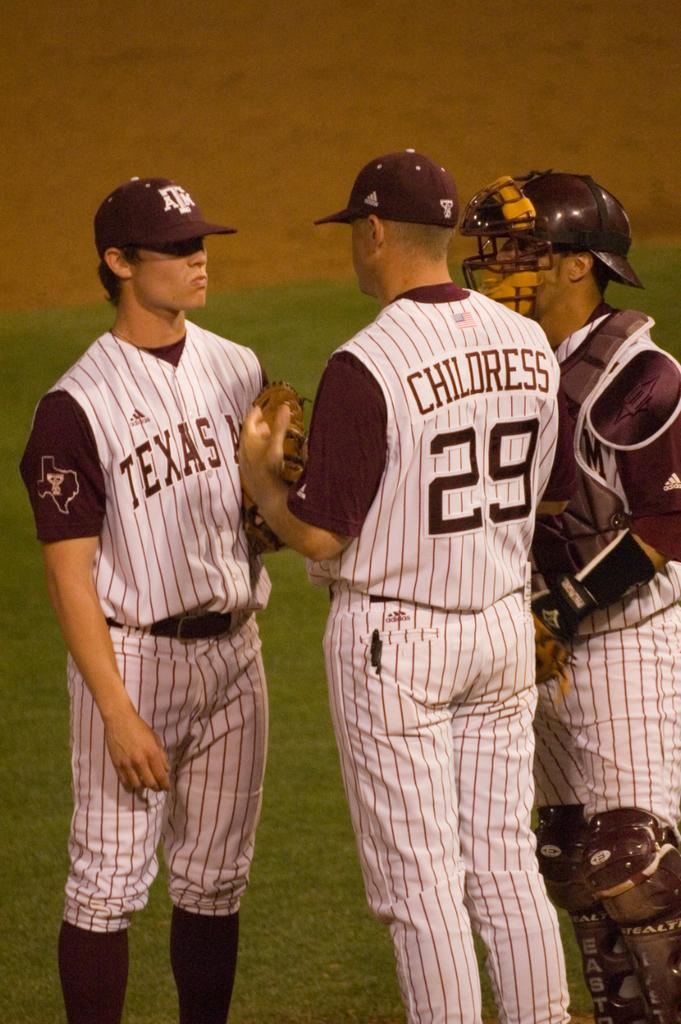What state is on the shirt of the men?
Provide a short and direct response. Texas. What number is childress?
Your answer should be very brief. 29. 